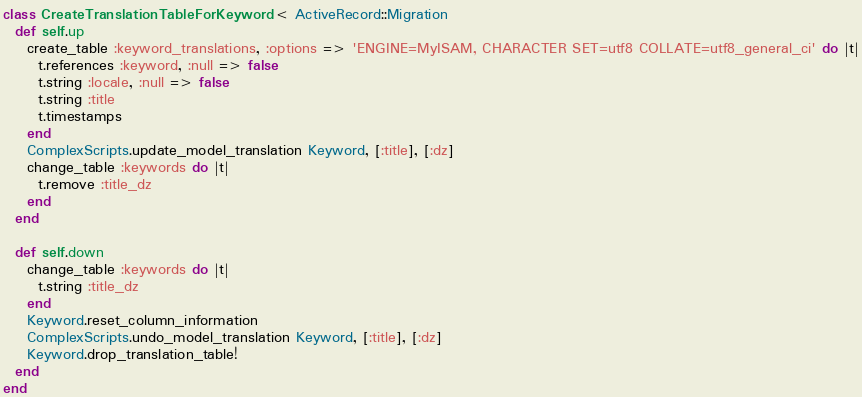Convert code to text. <code><loc_0><loc_0><loc_500><loc_500><_Ruby_>class CreateTranslationTableForKeyword < ActiveRecord::Migration
  def self.up
    create_table :keyword_translations, :options => 'ENGINE=MyISAM, CHARACTER SET=utf8 COLLATE=utf8_general_ci' do |t|
      t.references :keyword, :null => false
      t.string :locale, :null => false
      t.string :title
      t.timestamps
    end
    ComplexScripts.update_model_translation Keyword, [:title], [:dz]
    change_table :keywords do |t|
      t.remove :title_dz
    end
  end

  def self.down
    change_table :keywords do |t|
      t.string :title_dz
    end
    Keyword.reset_column_information
    ComplexScripts.undo_model_translation Keyword, [:title], [:dz]
    Keyword.drop_translation_table!
  end
end
</code> 